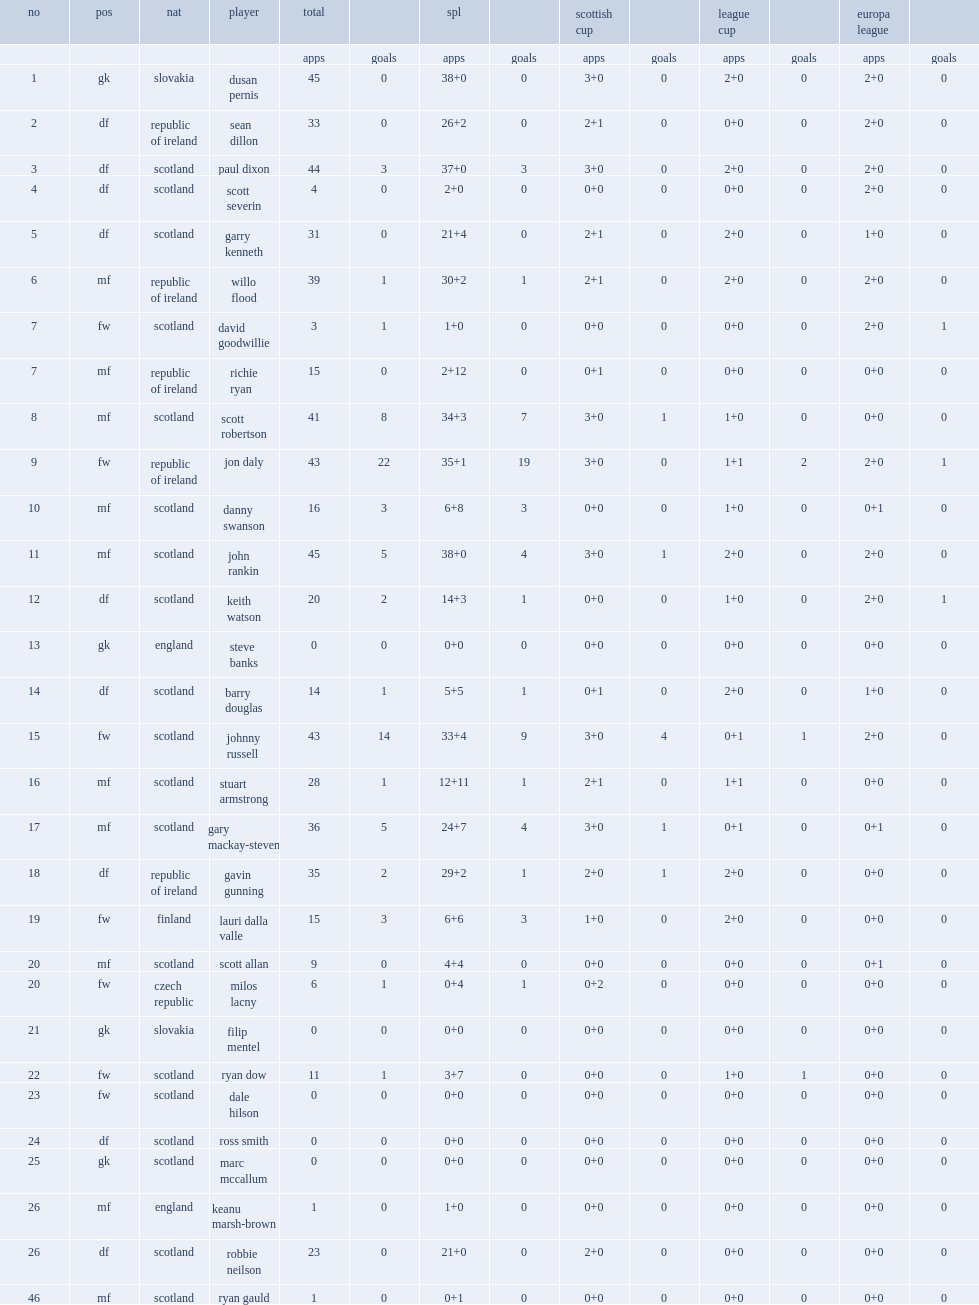What matches did dundee united competed in? Spl scottish cup league cup europa league. 